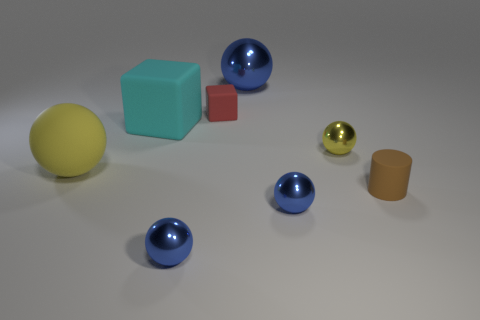What shape is the shiny object that is the same color as the rubber ball?
Give a very brief answer. Sphere. Are there any objects?
Offer a very short reply. Yes. Is the shape of the metal thing to the left of the small rubber block the same as the small metal thing behind the big matte ball?
Provide a succinct answer. Yes. What number of tiny objects are either yellow metallic objects or yellow spheres?
Your answer should be compact. 1. There is a brown thing that is the same material as the tiny cube; what is its shape?
Your answer should be very brief. Cylinder. Does the yellow shiny thing have the same shape as the big blue metal thing?
Provide a succinct answer. Yes. The rubber sphere has what color?
Your response must be concise. Yellow. What number of objects are brown metal cylinders or tiny matte things?
Provide a short and direct response. 2. Are there any other things that have the same material as the brown cylinder?
Make the answer very short. Yes. Are there fewer big blue spheres that are in front of the big matte block than red rubber blocks?
Provide a succinct answer. Yes. 